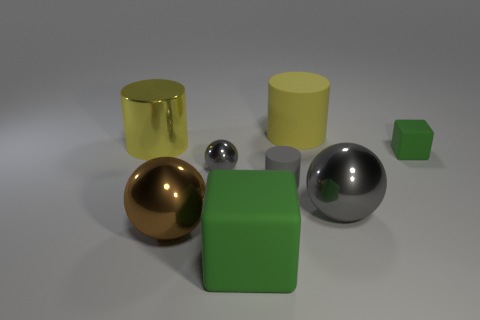Subtract all tiny gray rubber cylinders. How many cylinders are left? 2 Subtract all blue cylinders. How many gray spheres are left? 2 Subtract 1 balls. How many balls are left? 2 Add 1 big metallic balls. How many objects exist? 9 Subtract all red spheres. Subtract all red blocks. How many spheres are left? 3 Subtract all cubes. How many objects are left? 6 Add 3 big gray rubber cylinders. How many big gray rubber cylinders exist? 3 Subtract 0 green cylinders. How many objects are left? 8 Subtract all tiny cylinders. Subtract all green blocks. How many objects are left? 5 Add 5 tiny green rubber things. How many tiny green rubber things are left? 6 